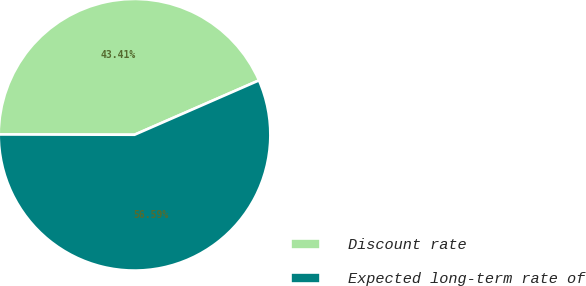Convert chart to OTSL. <chart><loc_0><loc_0><loc_500><loc_500><pie_chart><fcel>Discount rate<fcel>Expected long-term rate of<nl><fcel>43.41%<fcel>56.59%<nl></chart> 